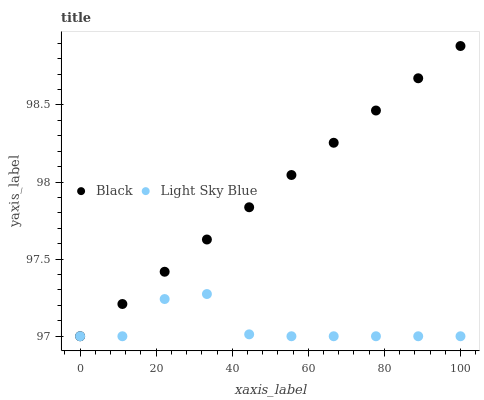Does Light Sky Blue have the minimum area under the curve?
Answer yes or no. Yes. Does Black have the maximum area under the curve?
Answer yes or no. Yes. Does Black have the minimum area under the curve?
Answer yes or no. No. Is Black the smoothest?
Answer yes or no. Yes. Is Light Sky Blue the roughest?
Answer yes or no. Yes. Is Black the roughest?
Answer yes or no. No. Does Light Sky Blue have the lowest value?
Answer yes or no. Yes. Does Black have the highest value?
Answer yes or no. Yes. Does Light Sky Blue intersect Black?
Answer yes or no. Yes. Is Light Sky Blue less than Black?
Answer yes or no. No. Is Light Sky Blue greater than Black?
Answer yes or no. No. 